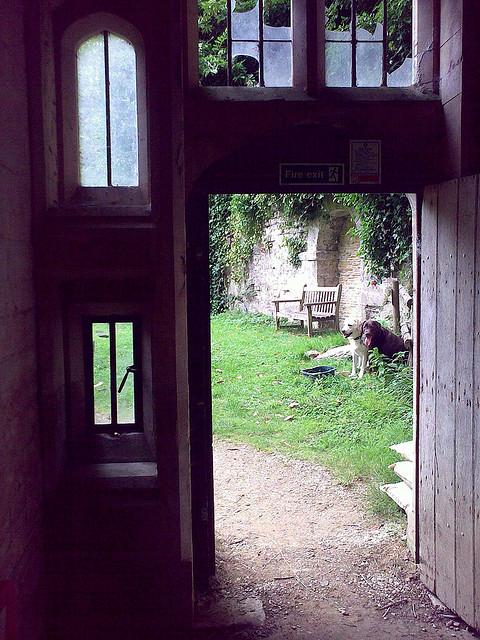Are some panes broken?
Write a very short answer. Yes. What color is the window frame?
Concise answer only. Brown. How many dogs are there?
Be succinct. 2. Does the grass need cut?
Concise answer only. Yes. Is that a chair outside?
Short answer required. Yes. What season is it in the picture?
Concise answer only. Summer. What kind of metal is beside the door?
Quick response, please. Iron. What color is the barn?
Give a very brief answer. Brown. 